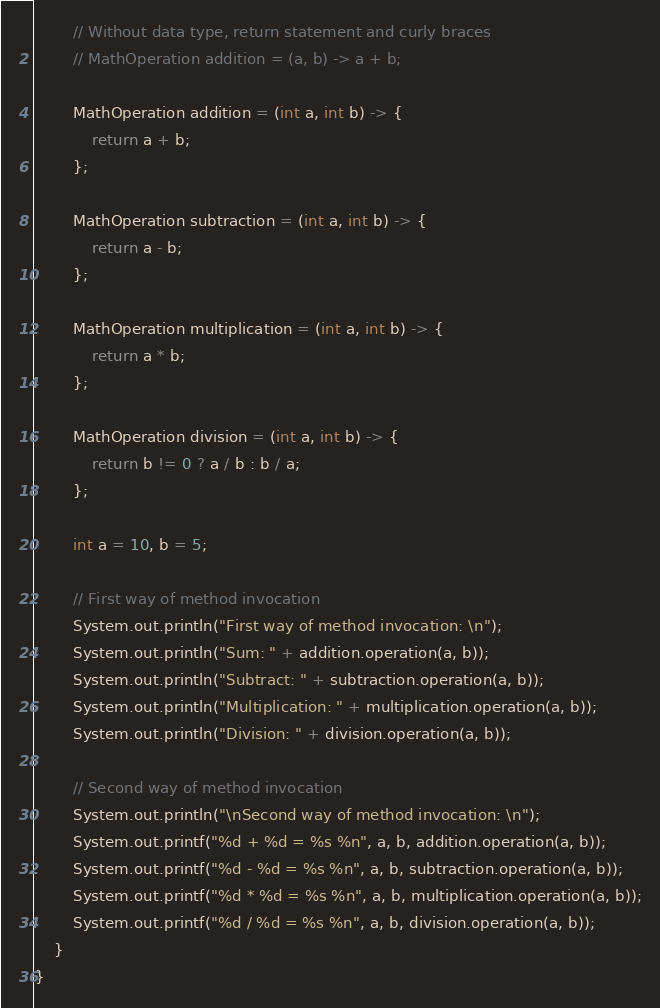<code> <loc_0><loc_0><loc_500><loc_500><_Java_>
        // Without data type, return statement and curly braces
        // MathOperation addition = (a, b) -> a + b;

        MathOperation addition = (int a, int b) -> {
            return a + b;
        };

        MathOperation subtraction = (int a, int b) -> {
            return a - b;
        };

        MathOperation multiplication = (int a, int b) -> {
            return a * b;
        };

        MathOperation division = (int a, int b) -> {
            return b != 0 ? a / b : b / a;
        };

        int a = 10, b = 5;

        // First way of method invocation
        System.out.println("First way of method invocation: \n");
        System.out.println("Sum: " + addition.operation(a, b));
        System.out.println("Subtract: " + subtraction.operation(a, b));
        System.out.println("Multiplication: " + multiplication.operation(a, b));
        System.out.println("Division: " + division.operation(a, b));

        // Second way of method invocation
        System.out.println("\nSecond way of method invocation: \n");
        System.out.printf("%d + %d = %s %n", a, b, addition.operation(a, b));
        System.out.printf("%d - %d = %s %n", a, b, subtraction.operation(a, b));
        System.out.printf("%d * %d = %s %n", a, b, multiplication.operation(a, b));
        System.out.printf("%d / %d = %s %n", a, b, division.operation(a, b));
    }
}
</code> 